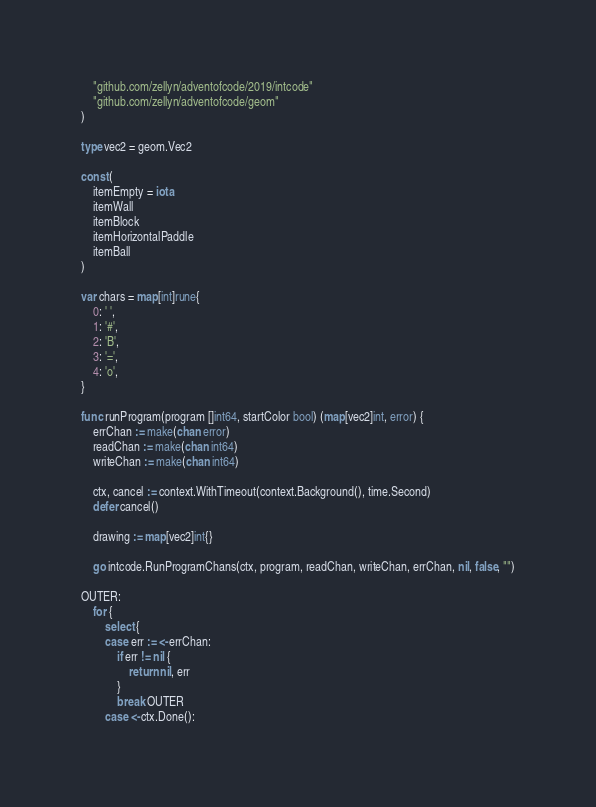Convert code to text. <code><loc_0><loc_0><loc_500><loc_500><_Go_>	"github.com/zellyn/adventofcode/2019/intcode"
	"github.com/zellyn/adventofcode/geom"
)

type vec2 = geom.Vec2

const (
	itemEmpty = iota
	itemWall
	itemBlock
	itemHorizontalPaddle
	itemBall
)

var chars = map[int]rune{
	0: ' ',
	1: '#',
	2: 'B',
	3: '=',
	4: 'o',
}

func runProgram(program []int64, startColor bool) (map[vec2]int, error) {
	errChan := make(chan error)
	readChan := make(chan int64)
	writeChan := make(chan int64)

	ctx, cancel := context.WithTimeout(context.Background(), time.Second)
	defer cancel()

	drawing := map[vec2]int{}

	go intcode.RunProgramChans(ctx, program, readChan, writeChan, errChan, nil, false, "")

OUTER:
	for {
		select {
		case err := <-errChan:
			if err != nil {
				return nil, err
			}
			break OUTER
		case <-ctx.Done():</code> 